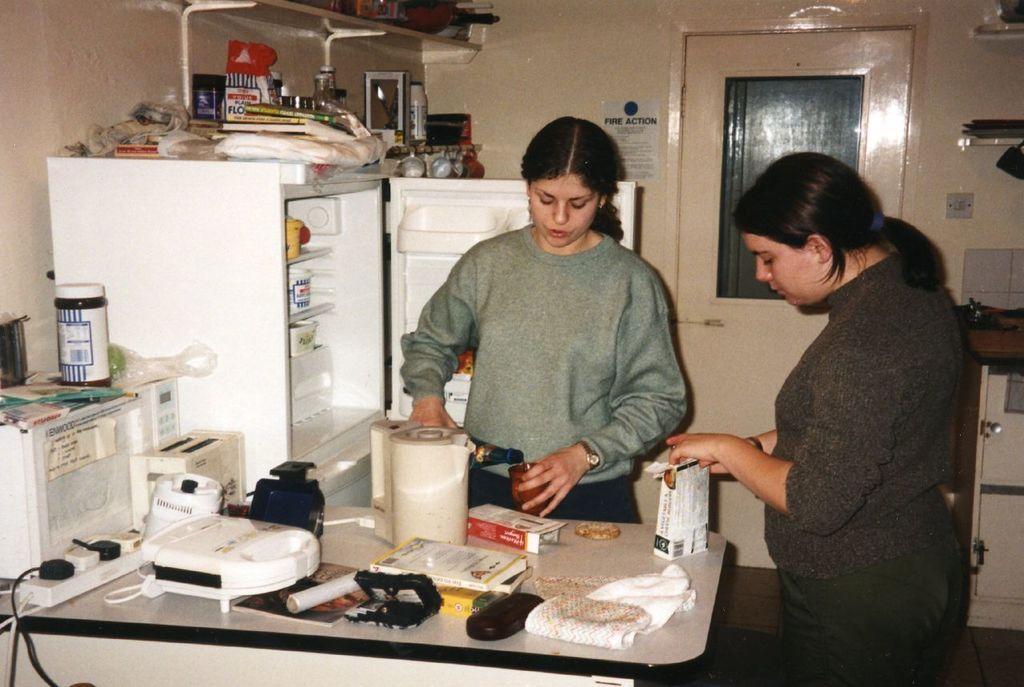In one or two sentences, can you explain what this image depicts? This Image is clicked in a room where there is a refrigerator on the left side, there is a door on the back, there are two women standing, there is a table in front of them. On the table there is a box, cloth, tissue roll. 